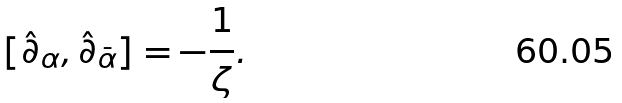<formula> <loc_0><loc_0><loc_500><loc_500>[ \hat { \partial } _ { \alpha } , \hat { \partial } _ { \bar { \alpha } } ] = - \frac { 1 } { \zeta } .</formula> 